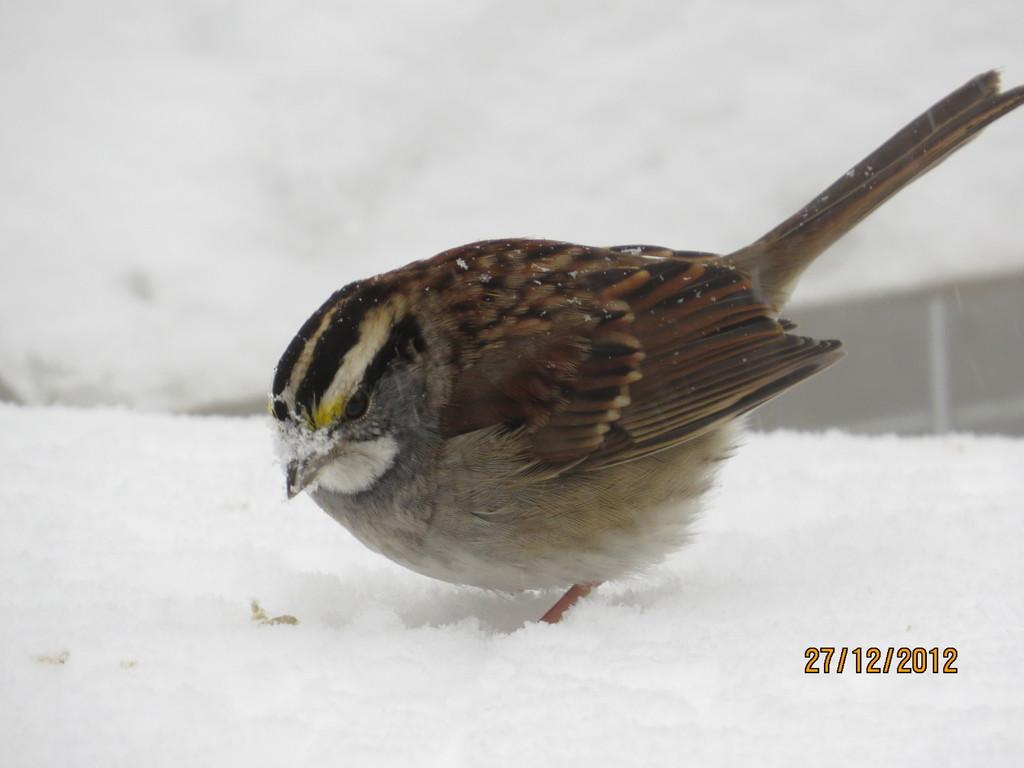What type of animal is in the image? There is a bird in the image. Can you describe the colors of the bird? The bird has white, black, light brown, and gray colors. What can be seen in the background of the image? There is snow in the background of the image. What is the weight of the airplane in the image? There is no airplane present in the image, so it is not possible to determine its weight. 